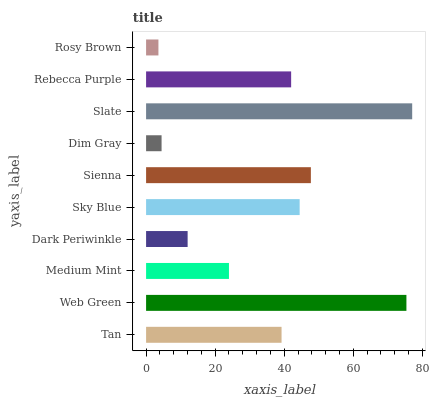Is Rosy Brown the minimum?
Answer yes or no. Yes. Is Slate the maximum?
Answer yes or no. Yes. Is Web Green the minimum?
Answer yes or no. No. Is Web Green the maximum?
Answer yes or no. No. Is Web Green greater than Tan?
Answer yes or no. Yes. Is Tan less than Web Green?
Answer yes or no. Yes. Is Tan greater than Web Green?
Answer yes or no. No. Is Web Green less than Tan?
Answer yes or no. No. Is Rebecca Purple the high median?
Answer yes or no. Yes. Is Tan the low median?
Answer yes or no. Yes. Is Web Green the high median?
Answer yes or no. No. Is Sienna the low median?
Answer yes or no. No. 